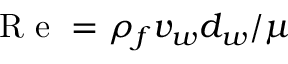Convert formula to latex. <formula><loc_0><loc_0><loc_500><loc_500>R e = \rho _ { f } v _ { w } d _ { w } / \mu</formula> 